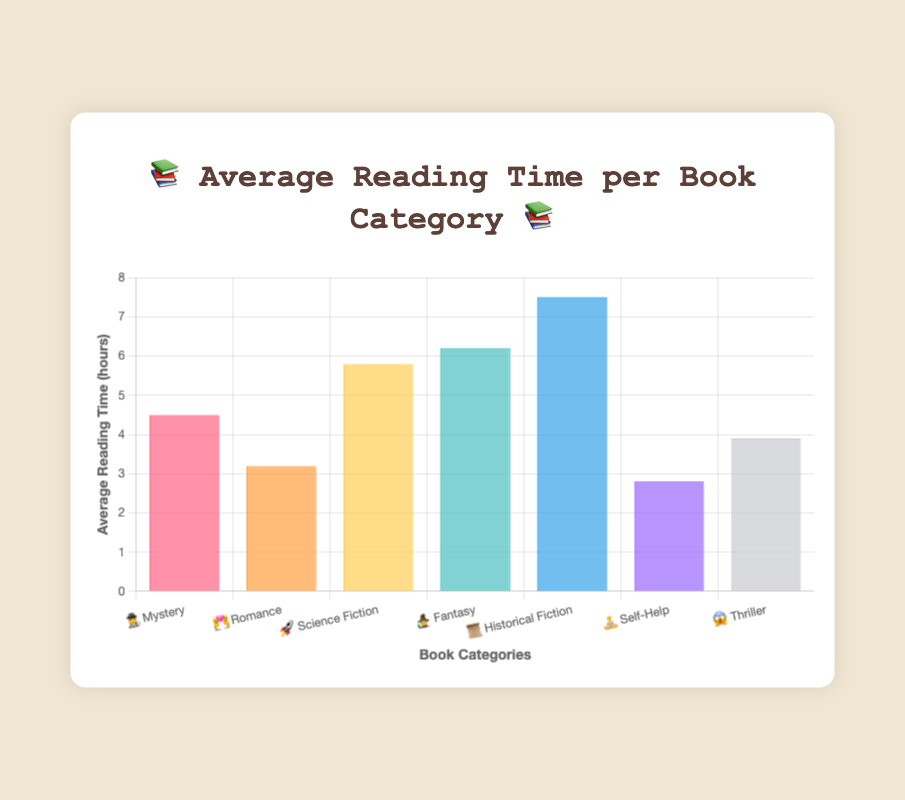What is the title of the chart? The title of the chart is displayed prominently at the top of the figure, reading "📚 Average Reading Time per Book Category 📚"
Answer: 📚 Average Reading Time per Book Category 📚 Which category has the shortest average reading time? By observing the bars, the "🧘 Self-Help" category has the shortest bar, indicating the shortest average reading time of 2.8 hours
Answer: 🧘 Self-Help What is the average reading time for the Mystery category? The bar for the "🕵️ Mystery" category goes up to 4.5 on the y-axis
Answer: 4.5 hours How many book categories are represented in the chart? Count the total number of bars or the labels on the x-axis, which represent the book categories. There are 7 categories in total
Answer: 7 Which category has the longest average reading time? By checking the height of the bars, the "📜 Historical Fiction" category has the tallest bar, indicating the longest average reading time at 7.5 hours
Answer: 📜 Historical Fiction How much longer is the average reading time for Fantasy books compared to Self-Help books? The average time for "🧙 Fantasy" is 6.2 hours and for "🧘 Self-Help" is 2.8 hours. The difference is 6.2 - 2.8 = 3.4 hours
Answer: 3.4 hours Which two categories combined have an average reading time close to the Historical Fiction category? "Science Fiction" (5.8) and "Mystery" (4.5) together sum up to 10.3, which is closer to 7.5 compared to other combinations
Answer: Science Fiction and Mystery Is the average reading time for Romance books greater than Thriller books? The average reading time for "💑 Romance" is 3.2 hours, whereas for "😱 Thriller" is 3.9 hours. Thus, the Thriller category has a greater average reading time
Answer: No Which category's average reading time exceeds 5 hours but is less than 6 hours? The categories within this range are "🚀 Science Fiction" at 5.8 hours
Answer: 🚀 Science Fiction 